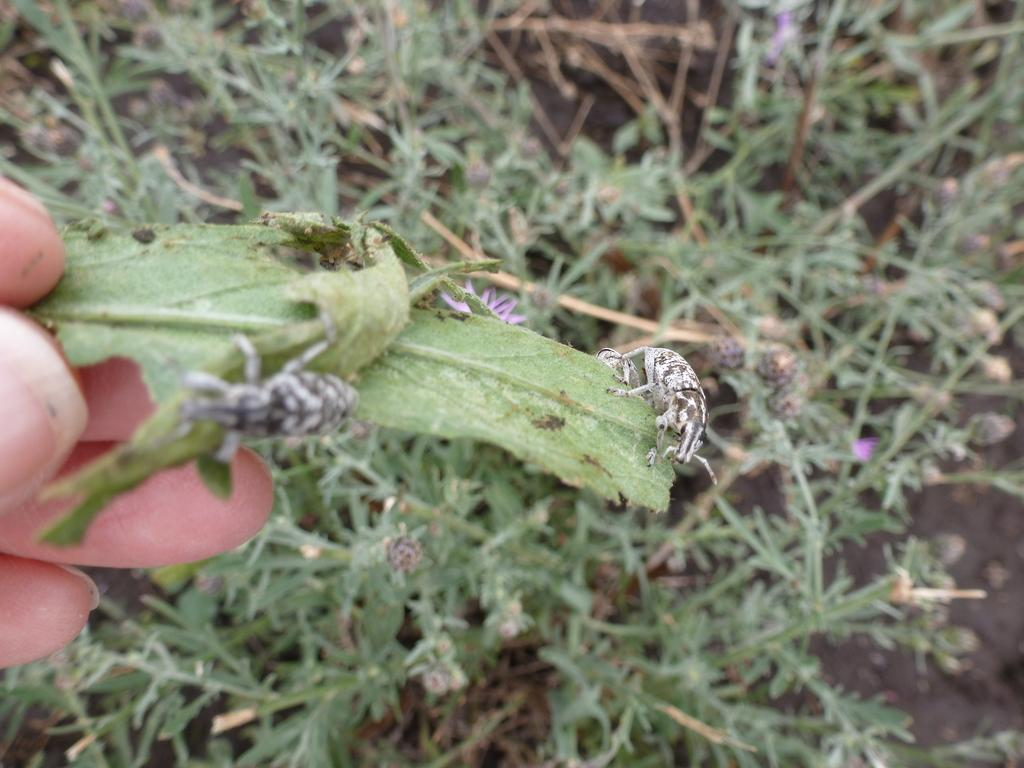Who or what is present in the image? There is a person in the image. What is the person holding in the image? The person is holding a leaf in the image. What can be found on the leaf? There are insects on the leaf. What type of vegetation is visible in the image? There are plants visible in the image. What is the ground made of in the image? There is mud in the image. What type of string can be seen tied around the person's waist in the image? There is no string tied around the person's waist in the image. What side of the person is the leaf being held on in the image? The image does not specify which side of the person is holding the leaf. 